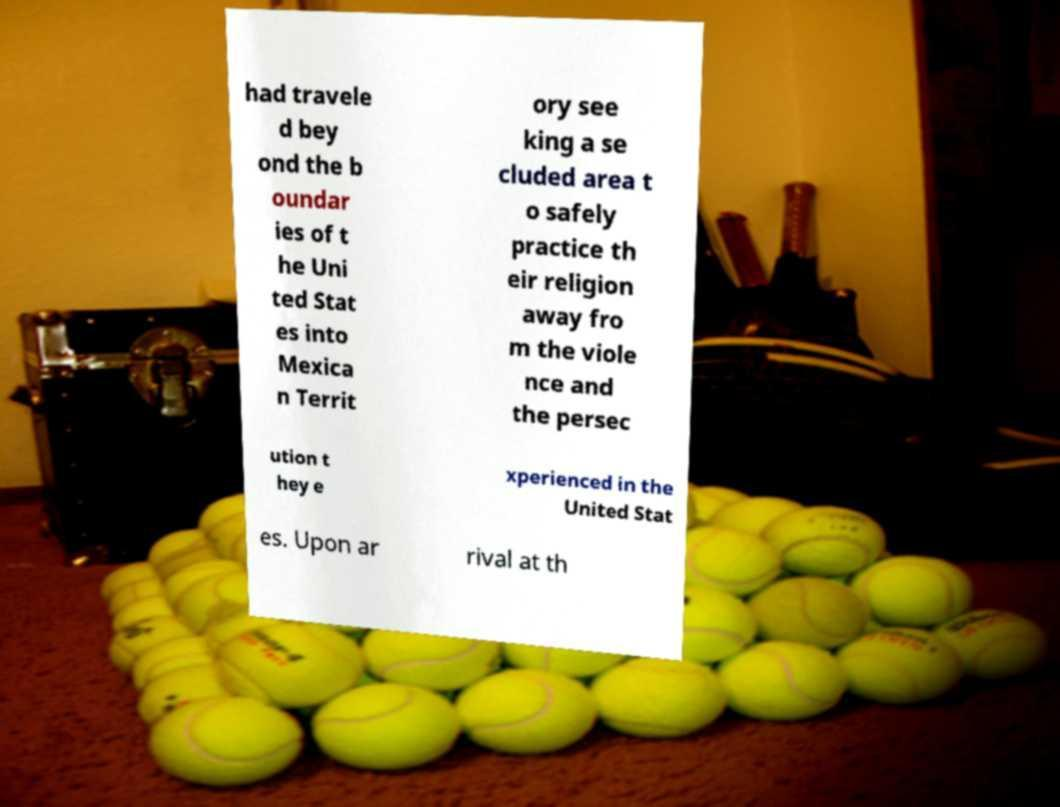Please read and relay the text visible in this image. What does it say? had travele d bey ond the b oundar ies of t he Uni ted Stat es into Mexica n Territ ory see king a se cluded area t o safely practice th eir religion away fro m the viole nce and the persec ution t hey e xperienced in the United Stat es. Upon ar rival at th 